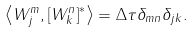<formula> <loc_0><loc_0><loc_500><loc_500>\left \langle W _ { j } ^ { m } , \left [ W _ { k } ^ { n } \right ] ^ { \ast } \right \rangle = \Delta \tau \delta _ { m n } \delta _ { j k } .</formula> 